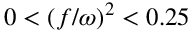<formula> <loc_0><loc_0><loc_500><loc_500>0 < \left ( f / \omega \right ) ^ { 2 } < 0 . 2 5</formula> 